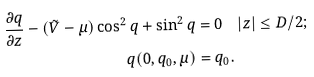<formula> <loc_0><loc_0><loc_500><loc_500>\frac { \partial q } { \partial z } - ( \tilde { V } - \mu ) \cos ^ { 2 } q + \sin ^ { 2 } q & = 0 \quad | z | \leq D / 2 ; \\ q ( 0 , q _ { 0 } , \mu ) & = q _ { 0 } .</formula> 